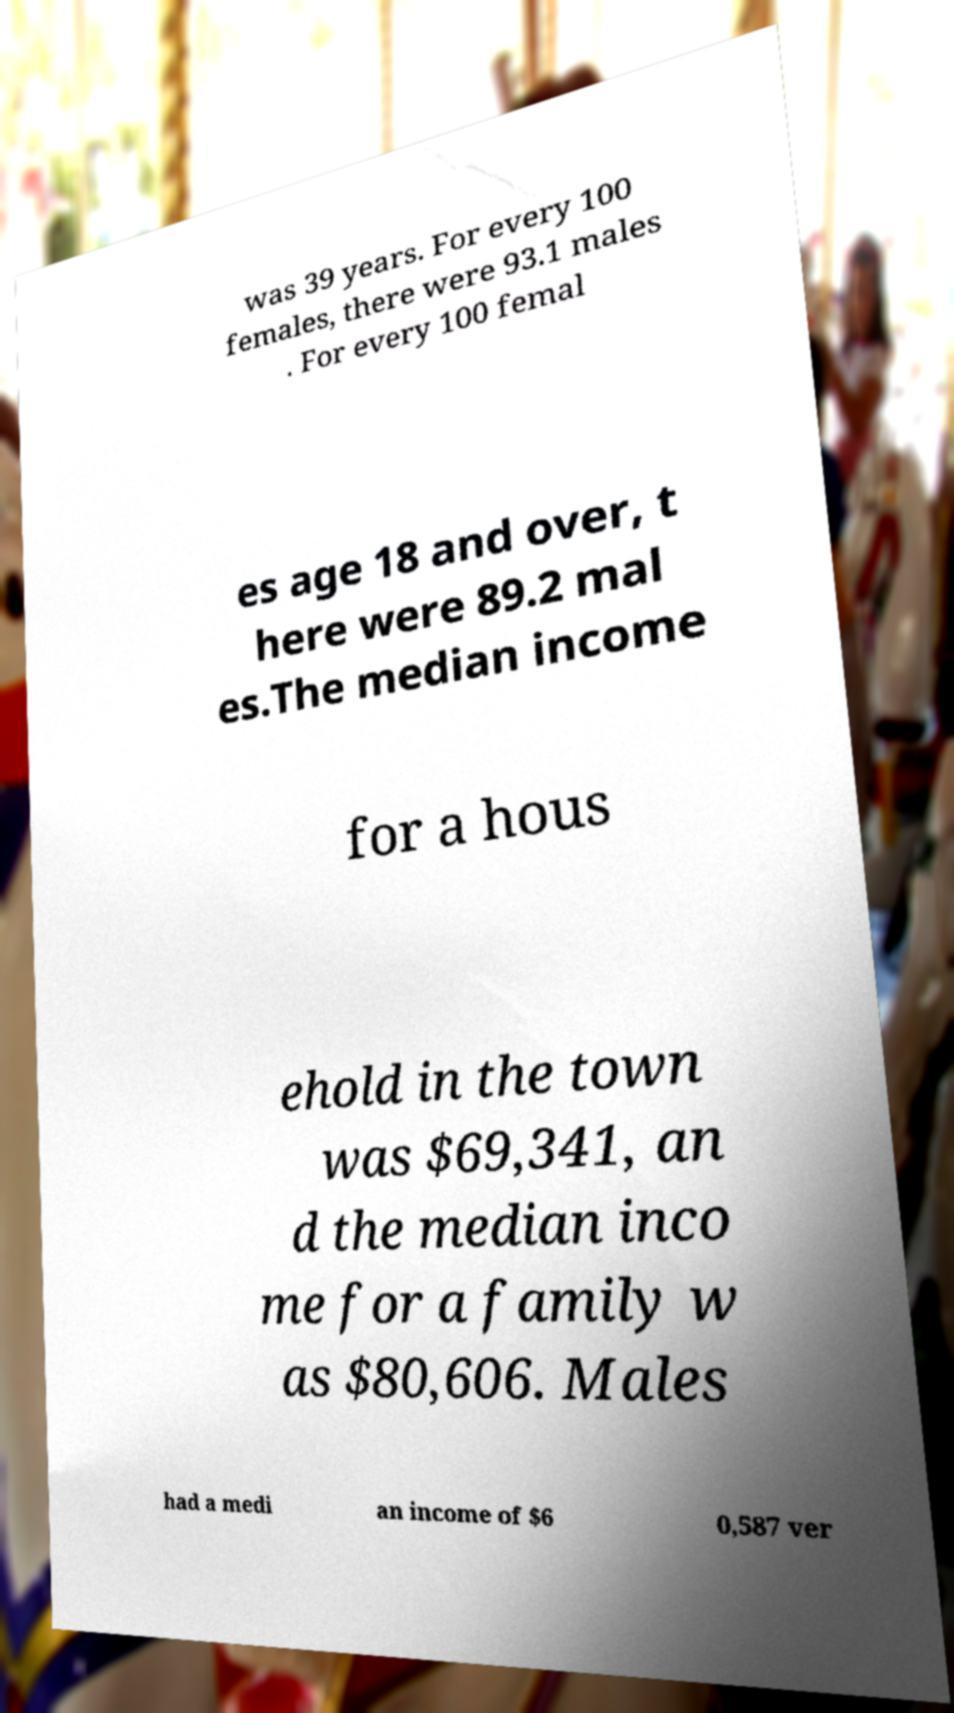Please read and relay the text visible in this image. What does it say? was 39 years. For every 100 females, there were 93.1 males . For every 100 femal es age 18 and over, t here were 89.2 mal es.The median income for a hous ehold in the town was $69,341, an d the median inco me for a family w as $80,606. Males had a medi an income of $6 0,587 ver 